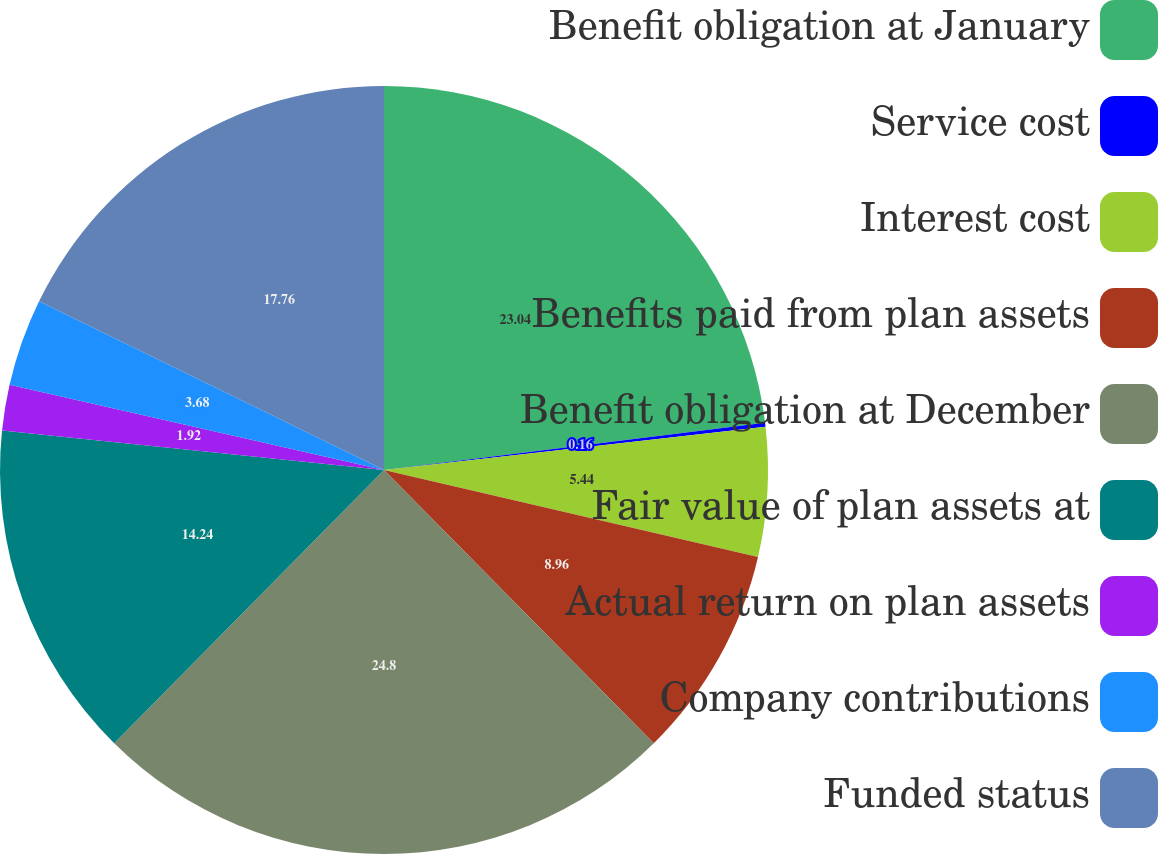Convert chart. <chart><loc_0><loc_0><loc_500><loc_500><pie_chart><fcel>Benefit obligation at January<fcel>Service cost<fcel>Interest cost<fcel>Benefits paid from plan assets<fcel>Benefit obligation at December<fcel>Fair value of plan assets at<fcel>Actual return on plan assets<fcel>Company contributions<fcel>Funded status<nl><fcel>23.04%<fcel>0.16%<fcel>5.44%<fcel>8.96%<fcel>24.8%<fcel>14.24%<fcel>1.92%<fcel>3.68%<fcel>17.76%<nl></chart> 